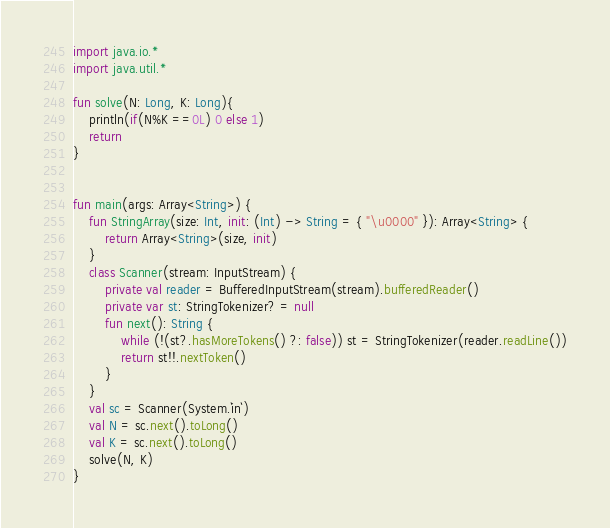<code> <loc_0><loc_0><loc_500><loc_500><_Kotlin_>import java.io.*
import java.util.*

fun solve(N: Long, K: Long){
    println(if(N%K ==0L) 0 else 1)
    return
}


fun main(args: Array<String>) {
    fun StringArray(size: Int, init: (Int) -> String = { "\u0000" }): Array<String> {
        return Array<String>(size, init)
    }
    class Scanner(stream: InputStream) {
        private val reader = BufferedInputStream(stream).bufferedReader()
        private var st: StringTokenizer? = null
        fun next(): String {
            while (!(st?.hasMoreTokens() ?: false)) st = StringTokenizer(reader.readLine())
            return st!!.nextToken()
        }
    }
    val sc = Scanner(System.`in`)
    val N = sc.next().toLong()
    val K = sc.next().toLong()
    solve(N, K)
}

</code> 